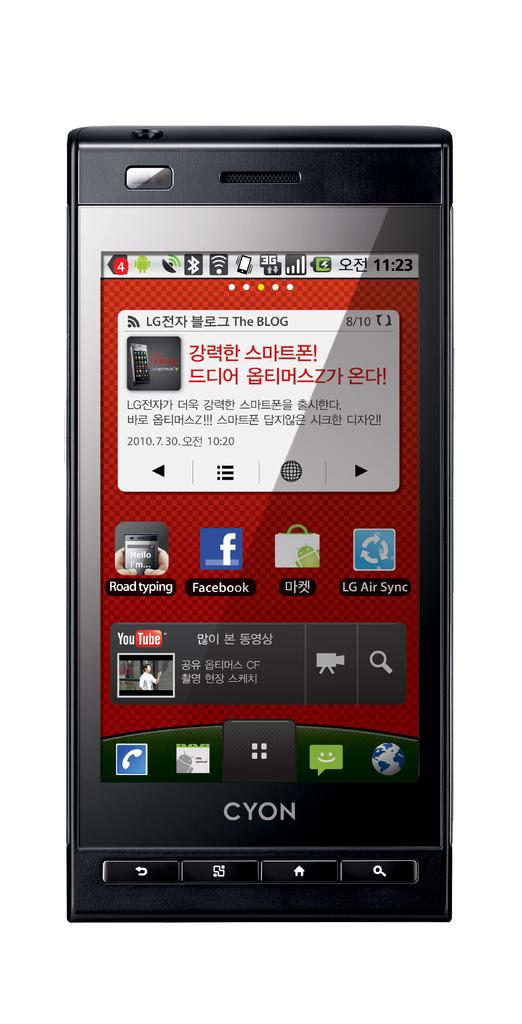What is the brand of phone?
Ensure brevity in your answer.  Cyon. What time is it?
Offer a very short reply. 11:23. 